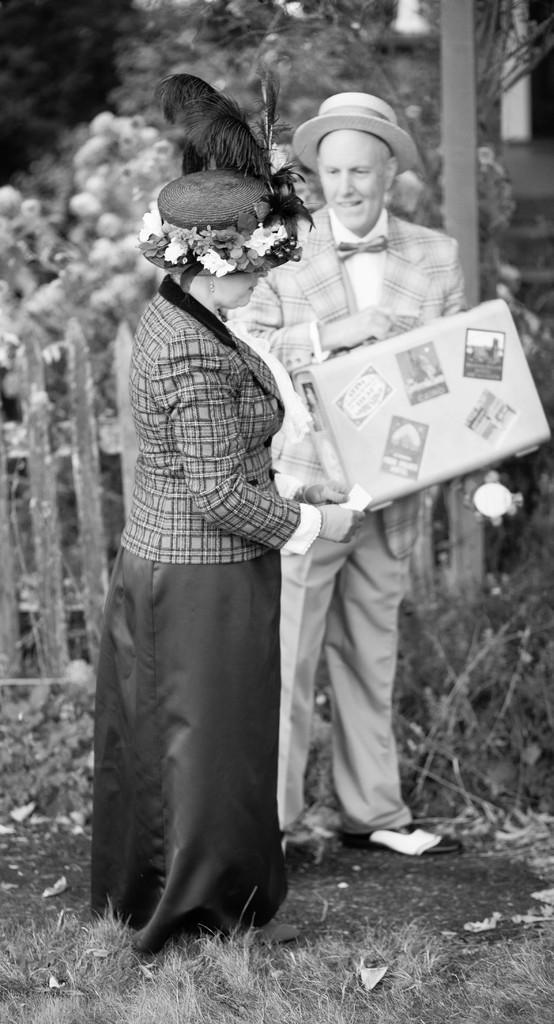Please provide a concise description of this image. This is a black and white image. There are a few people holding some objects. We can see the ground with some grass and objects. We can also see the fence and some trees. We can also see some objects on the right. 